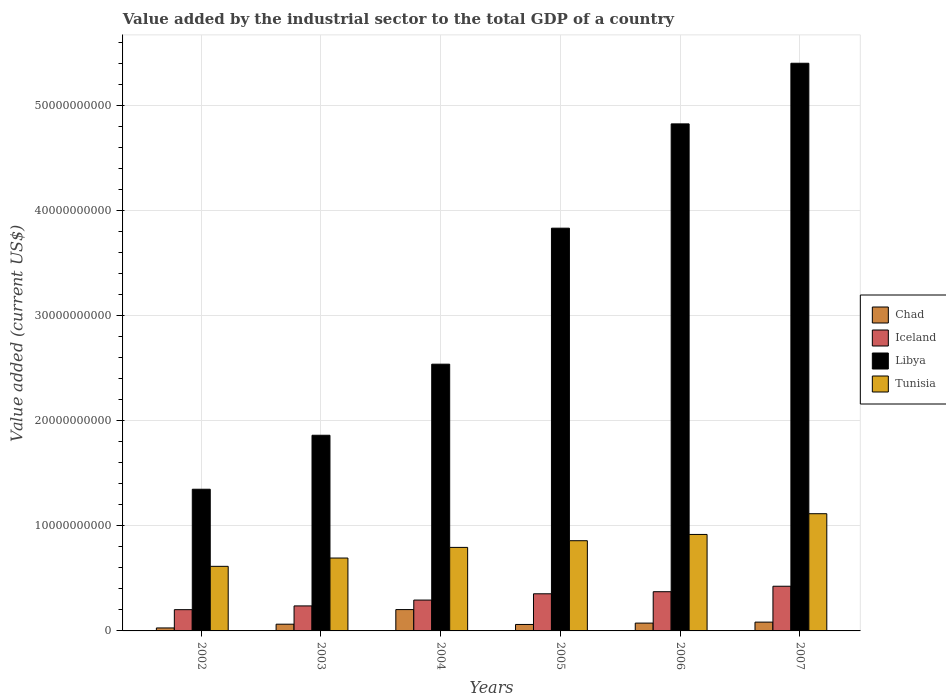How many groups of bars are there?
Make the answer very short. 6. Are the number of bars per tick equal to the number of legend labels?
Make the answer very short. Yes. Are the number of bars on each tick of the X-axis equal?
Provide a short and direct response. Yes. How many bars are there on the 5th tick from the left?
Your response must be concise. 4. How many bars are there on the 3rd tick from the right?
Offer a terse response. 4. What is the label of the 3rd group of bars from the left?
Give a very brief answer. 2004. In how many cases, is the number of bars for a given year not equal to the number of legend labels?
Offer a very short reply. 0. What is the value added by the industrial sector to the total GDP in Chad in 2003?
Your answer should be compact. 6.41e+08. Across all years, what is the maximum value added by the industrial sector to the total GDP in Chad?
Your answer should be compact. 2.03e+09. Across all years, what is the minimum value added by the industrial sector to the total GDP in Iceland?
Your answer should be compact. 2.02e+09. What is the total value added by the industrial sector to the total GDP in Libya in the graph?
Offer a terse response. 1.98e+11. What is the difference between the value added by the industrial sector to the total GDP in Iceland in 2002 and that in 2004?
Give a very brief answer. -9.14e+08. What is the difference between the value added by the industrial sector to the total GDP in Tunisia in 2007 and the value added by the industrial sector to the total GDP in Chad in 2006?
Provide a succinct answer. 1.04e+1. What is the average value added by the industrial sector to the total GDP in Iceland per year?
Your response must be concise. 3.14e+09. In the year 2004, what is the difference between the value added by the industrial sector to the total GDP in Iceland and value added by the industrial sector to the total GDP in Tunisia?
Give a very brief answer. -5.01e+09. What is the ratio of the value added by the industrial sector to the total GDP in Chad in 2003 to that in 2004?
Provide a succinct answer. 0.32. Is the difference between the value added by the industrial sector to the total GDP in Iceland in 2004 and 2007 greater than the difference between the value added by the industrial sector to the total GDP in Tunisia in 2004 and 2007?
Ensure brevity in your answer.  Yes. What is the difference between the highest and the second highest value added by the industrial sector to the total GDP in Chad?
Your answer should be compact. 1.19e+09. What is the difference between the highest and the lowest value added by the industrial sector to the total GDP in Chad?
Provide a short and direct response. 1.75e+09. In how many years, is the value added by the industrial sector to the total GDP in Chad greater than the average value added by the industrial sector to the total GDP in Chad taken over all years?
Provide a short and direct response. 1. Is the sum of the value added by the industrial sector to the total GDP in Iceland in 2003 and 2007 greater than the maximum value added by the industrial sector to the total GDP in Chad across all years?
Provide a short and direct response. Yes. What does the 2nd bar from the left in 2007 represents?
Offer a terse response. Iceland. What does the 3rd bar from the right in 2007 represents?
Make the answer very short. Iceland. How many years are there in the graph?
Provide a succinct answer. 6. What is the difference between two consecutive major ticks on the Y-axis?
Your answer should be compact. 1.00e+1. Are the values on the major ticks of Y-axis written in scientific E-notation?
Your response must be concise. No. Does the graph contain any zero values?
Offer a very short reply. No. Where does the legend appear in the graph?
Offer a terse response. Center right. How many legend labels are there?
Your answer should be compact. 4. What is the title of the graph?
Your response must be concise. Value added by the industrial sector to the total GDP of a country. Does "Kiribati" appear as one of the legend labels in the graph?
Your response must be concise. No. What is the label or title of the Y-axis?
Provide a succinct answer. Value added (current US$). What is the Value added (current US$) of Chad in 2002?
Your response must be concise. 2.83e+08. What is the Value added (current US$) in Iceland in 2002?
Offer a terse response. 2.02e+09. What is the Value added (current US$) in Libya in 2002?
Keep it short and to the point. 1.35e+1. What is the Value added (current US$) in Tunisia in 2002?
Offer a very short reply. 6.15e+09. What is the Value added (current US$) of Chad in 2003?
Provide a short and direct response. 6.41e+08. What is the Value added (current US$) in Iceland in 2003?
Keep it short and to the point. 2.38e+09. What is the Value added (current US$) in Libya in 2003?
Your answer should be very brief. 1.86e+1. What is the Value added (current US$) of Tunisia in 2003?
Make the answer very short. 6.94e+09. What is the Value added (current US$) in Chad in 2004?
Your response must be concise. 2.03e+09. What is the Value added (current US$) of Iceland in 2004?
Offer a terse response. 2.94e+09. What is the Value added (current US$) in Libya in 2004?
Offer a very short reply. 2.54e+1. What is the Value added (current US$) in Tunisia in 2004?
Make the answer very short. 7.95e+09. What is the Value added (current US$) of Chad in 2005?
Provide a short and direct response. 6.14e+08. What is the Value added (current US$) in Iceland in 2005?
Offer a very short reply. 3.53e+09. What is the Value added (current US$) in Libya in 2005?
Make the answer very short. 3.83e+1. What is the Value added (current US$) in Tunisia in 2005?
Your answer should be very brief. 8.59e+09. What is the Value added (current US$) in Chad in 2006?
Your answer should be compact. 7.45e+08. What is the Value added (current US$) of Iceland in 2006?
Your answer should be compact. 3.73e+09. What is the Value added (current US$) of Libya in 2006?
Provide a short and direct response. 4.83e+1. What is the Value added (current US$) in Tunisia in 2006?
Your answer should be compact. 9.18e+09. What is the Value added (current US$) of Chad in 2007?
Make the answer very short. 8.38e+08. What is the Value added (current US$) of Iceland in 2007?
Offer a terse response. 4.25e+09. What is the Value added (current US$) in Libya in 2007?
Offer a terse response. 5.40e+1. What is the Value added (current US$) of Tunisia in 2007?
Offer a very short reply. 1.12e+1. Across all years, what is the maximum Value added (current US$) of Chad?
Offer a terse response. 2.03e+09. Across all years, what is the maximum Value added (current US$) of Iceland?
Offer a very short reply. 4.25e+09. Across all years, what is the maximum Value added (current US$) in Libya?
Give a very brief answer. 5.40e+1. Across all years, what is the maximum Value added (current US$) of Tunisia?
Your answer should be very brief. 1.12e+1. Across all years, what is the minimum Value added (current US$) in Chad?
Provide a short and direct response. 2.83e+08. Across all years, what is the minimum Value added (current US$) in Iceland?
Your answer should be compact. 2.02e+09. Across all years, what is the minimum Value added (current US$) in Libya?
Your answer should be compact. 1.35e+1. Across all years, what is the minimum Value added (current US$) in Tunisia?
Ensure brevity in your answer.  6.15e+09. What is the total Value added (current US$) in Chad in the graph?
Give a very brief answer. 5.15e+09. What is the total Value added (current US$) of Iceland in the graph?
Offer a terse response. 1.89e+1. What is the total Value added (current US$) in Libya in the graph?
Keep it short and to the point. 1.98e+11. What is the total Value added (current US$) in Tunisia in the graph?
Make the answer very short. 5.00e+1. What is the difference between the Value added (current US$) in Chad in 2002 and that in 2003?
Give a very brief answer. -3.57e+08. What is the difference between the Value added (current US$) of Iceland in 2002 and that in 2003?
Your response must be concise. -3.58e+08. What is the difference between the Value added (current US$) of Libya in 2002 and that in 2003?
Ensure brevity in your answer.  -5.14e+09. What is the difference between the Value added (current US$) in Tunisia in 2002 and that in 2003?
Your answer should be very brief. -7.89e+08. What is the difference between the Value added (current US$) in Chad in 2002 and that in 2004?
Offer a very short reply. -1.75e+09. What is the difference between the Value added (current US$) of Iceland in 2002 and that in 2004?
Your answer should be very brief. -9.14e+08. What is the difference between the Value added (current US$) in Libya in 2002 and that in 2004?
Ensure brevity in your answer.  -1.19e+1. What is the difference between the Value added (current US$) of Tunisia in 2002 and that in 2004?
Your answer should be very brief. -1.80e+09. What is the difference between the Value added (current US$) of Chad in 2002 and that in 2005?
Provide a short and direct response. -3.31e+08. What is the difference between the Value added (current US$) of Iceland in 2002 and that in 2005?
Your answer should be very brief. -1.51e+09. What is the difference between the Value added (current US$) in Libya in 2002 and that in 2005?
Make the answer very short. -2.48e+1. What is the difference between the Value added (current US$) in Tunisia in 2002 and that in 2005?
Make the answer very short. -2.44e+09. What is the difference between the Value added (current US$) of Chad in 2002 and that in 2006?
Offer a very short reply. -4.61e+08. What is the difference between the Value added (current US$) of Iceland in 2002 and that in 2006?
Your answer should be very brief. -1.71e+09. What is the difference between the Value added (current US$) in Libya in 2002 and that in 2006?
Your answer should be compact. -3.48e+1. What is the difference between the Value added (current US$) in Tunisia in 2002 and that in 2006?
Ensure brevity in your answer.  -3.03e+09. What is the difference between the Value added (current US$) of Chad in 2002 and that in 2007?
Offer a terse response. -5.55e+08. What is the difference between the Value added (current US$) in Iceland in 2002 and that in 2007?
Keep it short and to the point. -2.23e+09. What is the difference between the Value added (current US$) in Libya in 2002 and that in 2007?
Offer a very short reply. -4.05e+1. What is the difference between the Value added (current US$) of Tunisia in 2002 and that in 2007?
Keep it short and to the point. -5.01e+09. What is the difference between the Value added (current US$) of Chad in 2003 and that in 2004?
Offer a terse response. -1.39e+09. What is the difference between the Value added (current US$) in Iceland in 2003 and that in 2004?
Keep it short and to the point. -5.56e+08. What is the difference between the Value added (current US$) of Libya in 2003 and that in 2004?
Offer a very short reply. -6.77e+09. What is the difference between the Value added (current US$) of Tunisia in 2003 and that in 2004?
Provide a short and direct response. -1.01e+09. What is the difference between the Value added (current US$) in Chad in 2003 and that in 2005?
Provide a short and direct response. 2.67e+07. What is the difference between the Value added (current US$) of Iceland in 2003 and that in 2005?
Give a very brief answer. -1.15e+09. What is the difference between the Value added (current US$) of Libya in 2003 and that in 2005?
Provide a short and direct response. -1.97e+1. What is the difference between the Value added (current US$) in Tunisia in 2003 and that in 2005?
Provide a succinct answer. -1.65e+09. What is the difference between the Value added (current US$) of Chad in 2003 and that in 2006?
Provide a short and direct response. -1.04e+08. What is the difference between the Value added (current US$) of Iceland in 2003 and that in 2006?
Make the answer very short. -1.35e+09. What is the difference between the Value added (current US$) of Libya in 2003 and that in 2006?
Offer a terse response. -2.96e+1. What is the difference between the Value added (current US$) of Tunisia in 2003 and that in 2006?
Your answer should be compact. -2.25e+09. What is the difference between the Value added (current US$) of Chad in 2003 and that in 2007?
Offer a terse response. -1.98e+08. What is the difference between the Value added (current US$) of Iceland in 2003 and that in 2007?
Your answer should be very brief. -1.87e+09. What is the difference between the Value added (current US$) of Libya in 2003 and that in 2007?
Give a very brief answer. -3.54e+1. What is the difference between the Value added (current US$) of Tunisia in 2003 and that in 2007?
Provide a succinct answer. -4.22e+09. What is the difference between the Value added (current US$) of Chad in 2004 and that in 2005?
Offer a very short reply. 1.42e+09. What is the difference between the Value added (current US$) in Iceland in 2004 and that in 2005?
Ensure brevity in your answer.  -5.97e+08. What is the difference between the Value added (current US$) in Libya in 2004 and that in 2005?
Your response must be concise. -1.29e+1. What is the difference between the Value added (current US$) of Tunisia in 2004 and that in 2005?
Your response must be concise. -6.36e+08. What is the difference between the Value added (current US$) of Chad in 2004 and that in 2006?
Keep it short and to the point. 1.29e+09. What is the difference between the Value added (current US$) in Iceland in 2004 and that in 2006?
Keep it short and to the point. -7.95e+08. What is the difference between the Value added (current US$) in Libya in 2004 and that in 2006?
Provide a short and direct response. -2.29e+1. What is the difference between the Value added (current US$) of Tunisia in 2004 and that in 2006?
Your answer should be compact. -1.23e+09. What is the difference between the Value added (current US$) of Chad in 2004 and that in 2007?
Offer a terse response. 1.19e+09. What is the difference between the Value added (current US$) in Iceland in 2004 and that in 2007?
Make the answer very short. -1.32e+09. What is the difference between the Value added (current US$) in Libya in 2004 and that in 2007?
Your response must be concise. -2.86e+1. What is the difference between the Value added (current US$) in Tunisia in 2004 and that in 2007?
Make the answer very short. -3.21e+09. What is the difference between the Value added (current US$) in Chad in 2005 and that in 2006?
Provide a short and direct response. -1.31e+08. What is the difference between the Value added (current US$) of Iceland in 2005 and that in 2006?
Your answer should be compact. -1.99e+08. What is the difference between the Value added (current US$) in Libya in 2005 and that in 2006?
Offer a very short reply. -9.93e+09. What is the difference between the Value added (current US$) in Tunisia in 2005 and that in 2006?
Provide a short and direct response. -5.96e+08. What is the difference between the Value added (current US$) of Chad in 2005 and that in 2007?
Make the answer very short. -2.24e+08. What is the difference between the Value added (current US$) of Iceland in 2005 and that in 2007?
Give a very brief answer. -7.18e+08. What is the difference between the Value added (current US$) of Libya in 2005 and that in 2007?
Your answer should be compact. -1.57e+1. What is the difference between the Value added (current US$) in Tunisia in 2005 and that in 2007?
Keep it short and to the point. -2.57e+09. What is the difference between the Value added (current US$) of Chad in 2006 and that in 2007?
Your response must be concise. -9.36e+07. What is the difference between the Value added (current US$) in Iceland in 2006 and that in 2007?
Ensure brevity in your answer.  -5.20e+08. What is the difference between the Value added (current US$) of Libya in 2006 and that in 2007?
Keep it short and to the point. -5.77e+09. What is the difference between the Value added (current US$) of Tunisia in 2006 and that in 2007?
Make the answer very short. -1.97e+09. What is the difference between the Value added (current US$) in Chad in 2002 and the Value added (current US$) in Iceland in 2003?
Your response must be concise. -2.10e+09. What is the difference between the Value added (current US$) in Chad in 2002 and the Value added (current US$) in Libya in 2003?
Your response must be concise. -1.83e+1. What is the difference between the Value added (current US$) of Chad in 2002 and the Value added (current US$) of Tunisia in 2003?
Your answer should be compact. -6.65e+09. What is the difference between the Value added (current US$) of Iceland in 2002 and the Value added (current US$) of Libya in 2003?
Ensure brevity in your answer.  -1.66e+1. What is the difference between the Value added (current US$) in Iceland in 2002 and the Value added (current US$) in Tunisia in 2003?
Make the answer very short. -4.91e+09. What is the difference between the Value added (current US$) in Libya in 2002 and the Value added (current US$) in Tunisia in 2003?
Offer a terse response. 6.55e+09. What is the difference between the Value added (current US$) in Chad in 2002 and the Value added (current US$) in Iceland in 2004?
Your response must be concise. -2.65e+09. What is the difference between the Value added (current US$) in Chad in 2002 and the Value added (current US$) in Libya in 2004?
Provide a short and direct response. -2.51e+1. What is the difference between the Value added (current US$) of Chad in 2002 and the Value added (current US$) of Tunisia in 2004?
Provide a short and direct response. -7.67e+09. What is the difference between the Value added (current US$) of Iceland in 2002 and the Value added (current US$) of Libya in 2004?
Your answer should be compact. -2.34e+1. What is the difference between the Value added (current US$) of Iceland in 2002 and the Value added (current US$) of Tunisia in 2004?
Give a very brief answer. -5.93e+09. What is the difference between the Value added (current US$) of Libya in 2002 and the Value added (current US$) of Tunisia in 2004?
Your answer should be compact. 5.53e+09. What is the difference between the Value added (current US$) in Chad in 2002 and the Value added (current US$) in Iceland in 2005?
Offer a terse response. -3.25e+09. What is the difference between the Value added (current US$) of Chad in 2002 and the Value added (current US$) of Libya in 2005?
Provide a short and direct response. -3.80e+1. What is the difference between the Value added (current US$) in Chad in 2002 and the Value added (current US$) in Tunisia in 2005?
Give a very brief answer. -8.30e+09. What is the difference between the Value added (current US$) of Iceland in 2002 and the Value added (current US$) of Libya in 2005?
Give a very brief answer. -3.63e+1. What is the difference between the Value added (current US$) in Iceland in 2002 and the Value added (current US$) in Tunisia in 2005?
Your answer should be compact. -6.56e+09. What is the difference between the Value added (current US$) in Libya in 2002 and the Value added (current US$) in Tunisia in 2005?
Give a very brief answer. 4.90e+09. What is the difference between the Value added (current US$) in Chad in 2002 and the Value added (current US$) in Iceland in 2006?
Ensure brevity in your answer.  -3.45e+09. What is the difference between the Value added (current US$) in Chad in 2002 and the Value added (current US$) in Libya in 2006?
Keep it short and to the point. -4.80e+1. What is the difference between the Value added (current US$) in Chad in 2002 and the Value added (current US$) in Tunisia in 2006?
Provide a short and direct response. -8.90e+09. What is the difference between the Value added (current US$) of Iceland in 2002 and the Value added (current US$) of Libya in 2006?
Give a very brief answer. -4.62e+1. What is the difference between the Value added (current US$) of Iceland in 2002 and the Value added (current US$) of Tunisia in 2006?
Make the answer very short. -7.16e+09. What is the difference between the Value added (current US$) of Libya in 2002 and the Value added (current US$) of Tunisia in 2006?
Your answer should be very brief. 4.30e+09. What is the difference between the Value added (current US$) of Chad in 2002 and the Value added (current US$) of Iceland in 2007?
Make the answer very short. -3.97e+09. What is the difference between the Value added (current US$) of Chad in 2002 and the Value added (current US$) of Libya in 2007?
Provide a succinct answer. -5.37e+1. What is the difference between the Value added (current US$) in Chad in 2002 and the Value added (current US$) in Tunisia in 2007?
Make the answer very short. -1.09e+1. What is the difference between the Value added (current US$) of Iceland in 2002 and the Value added (current US$) of Libya in 2007?
Provide a succinct answer. -5.20e+1. What is the difference between the Value added (current US$) in Iceland in 2002 and the Value added (current US$) in Tunisia in 2007?
Your answer should be very brief. -9.13e+09. What is the difference between the Value added (current US$) in Libya in 2002 and the Value added (current US$) in Tunisia in 2007?
Give a very brief answer. 2.33e+09. What is the difference between the Value added (current US$) of Chad in 2003 and the Value added (current US$) of Iceland in 2004?
Provide a succinct answer. -2.30e+09. What is the difference between the Value added (current US$) of Chad in 2003 and the Value added (current US$) of Libya in 2004?
Your response must be concise. -2.47e+1. What is the difference between the Value added (current US$) in Chad in 2003 and the Value added (current US$) in Tunisia in 2004?
Offer a terse response. -7.31e+09. What is the difference between the Value added (current US$) of Iceland in 2003 and the Value added (current US$) of Libya in 2004?
Keep it short and to the point. -2.30e+1. What is the difference between the Value added (current US$) of Iceland in 2003 and the Value added (current US$) of Tunisia in 2004?
Your answer should be compact. -5.57e+09. What is the difference between the Value added (current US$) in Libya in 2003 and the Value added (current US$) in Tunisia in 2004?
Offer a very short reply. 1.07e+1. What is the difference between the Value added (current US$) in Chad in 2003 and the Value added (current US$) in Iceland in 2005?
Your response must be concise. -2.89e+09. What is the difference between the Value added (current US$) of Chad in 2003 and the Value added (current US$) of Libya in 2005?
Your answer should be very brief. -3.77e+1. What is the difference between the Value added (current US$) in Chad in 2003 and the Value added (current US$) in Tunisia in 2005?
Provide a succinct answer. -7.94e+09. What is the difference between the Value added (current US$) of Iceland in 2003 and the Value added (current US$) of Libya in 2005?
Provide a short and direct response. -3.59e+1. What is the difference between the Value added (current US$) of Iceland in 2003 and the Value added (current US$) of Tunisia in 2005?
Give a very brief answer. -6.20e+09. What is the difference between the Value added (current US$) of Libya in 2003 and the Value added (current US$) of Tunisia in 2005?
Ensure brevity in your answer.  1.00e+1. What is the difference between the Value added (current US$) in Chad in 2003 and the Value added (current US$) in Iceland in 2006?
Give a very brief answer. -3.09e+09. What is the difference between the Value added (current US$) of Chad in 2003 and the Value added (current US$) of Libya in 2006?
Your answer should be compact. -4.76e+1. What is the difference between the Value added (current US$) in Chad in 2003 and the Value added (current US$) in Tunisia in 2006?
Make the answer very short. -8.54e+09. What is the difference between the Value added (current US$) in Iceland in 2003 and the Value added (current US$) in Libya in 2006?
Provide a short and direct response. -4.59e+1. What is the difference between the Value added (current US$) in Iceland in 2003 and the Value added (current US$) in Tunisia in 2006?
Ensure brevity in your answer.  -6.80e+09. What is the difference between the Value added (current US$) of Libya in 2003 and the Value added (current US$) of Tunisia in 2006?
Make the answer very short. 9.44e+09. What is the difference between the Value added (current US$) in Chad in 2003 and the Value added (current US$) in Iceland in 2007?
Ensure brevity in your answer.  -3.61e+09. What is the difference between the Value added (current US$) in Chad in 2003 and the Value added (current US$) in Libya in 2007?
Offer a very short reply. -5.34e+1. What is the difference between the Value added (current US$) of Chad in 2003 and the Value added (current US$) of Tunisia in 2007?
Your response must be concise. -1.05e+1. What is the difference between the Value added (current US$) of Iceland in 2003 and the Value added (current US$) of Libya in 2007?
Offer a terse response. -5.16e+1. What is the difference between the Value added (current US$) in Iceland in 2003 and the Value added (current US$) in Tunisia in 2007?
Give a very brief answer. -8.77e+09. What is the difference between the Value added (current US$) in Libya in 2003 and the Value added (current US$) in Tunisia in 2007?
Your response must be concise. 7.47e+09. What is the difference between the Value added (current US$) in Chad in 2004 and the Value added (current US$) in Iceland in 2005?
Your response must be concise. -1.50e+09. What is the difference between the Value added (current US$) in Chad in 2004 and the Value added (current US$) in Libya in 2005?
Offer a terse response. -3.63e+1. What is the difference between the Value added (current US$) of Chad in 2004 and the Value added (current US$) of Tunisia in 2005?
Offer a terse response. -6.56e+09. What is the difference between the Value added (current US$) in Iceland in 2004 and the Value added (current US$) in Libya in 2005?
Your answer should be compact. -3.54e+1. What is the difference between the Value added (current US$) of Iceland in 2004 and the Value added (current US$) of Tunisia in 2005?
Provide a succinct answer. -5.65e+09. What is the difference between the Value added (current US$) of Libya in 2004 and the Value added (current US$) of Tunisia in 2005?
Ensure brevity in your answer.  1.68e+1. What is the difference between the Value added (current US$) in Chad in 2004 and the Value added (current US$) in Iceland in 2006?
Offer a very short reply. -1.70e+09. What is the difference between the Value added (current US$) in Chad in 2004 and the Value added (current US$) in Libya in 2006?
Keep it short and to the point. -4.62e+1. What is the difference between the Value added (current US$) of Chad in 2004 and the Value added (current US$) of Tunisia in 2006?
Keep it short and to the point. -7.15e+09. What is the difference between the Value added (current US$) in Iceland in 2004 and the Value added (current US$) in Libya in 2006?
Offer a terse response. -4.53e+1. What is the difference between the Value added (current US$) of Iceland in 2004 and the Value added (current US$) of Tunisia in 2006?
Provide a short and direct response. -6.24e+09. What is the difference between the Value added (current US$) in Libya in 2004 and the Value added (current US$) in Tunisia in 2006?
Your response must be concise. 1.62e+1. What is the difference between the Value added (current US$) of Chad in 2004 and the Value added (current US$) of Iceland in 2007?
Make the answer very short. -2.22e+09. What is the difference between the Value added (current US$) in Chad in 2004 and the Value added (current US$) in Libya in 2007?
Your answer should be compact. -5.20e+1. What is the difference between the Value added (current US$) of Chad in 2004 and the Value added (current US$) of Tunisia in 2007?
Offer a very short reply. -9.12e+09. What is the difference between the Value added (current US$) in Iceland in 2004 and the Value added (current US$) in Libya in 2007?
Ensure brevity in your answer.  -5.11e+1. What is the difference between the Value added (current US$) in Iceland in 2004 and the Value added (current US$) in Tunisia in 2007?
Provide a succinct answer. -8.22e+09. What is the difference between the Value added (current US$) of Libya in 2004 and the Value added (current US$) of Tunisia in 2007?
Provide a short and direct response. 1.42e+1. What is the difference between the Value added (current US$) of Chad in 2005 and the Value added (current US$) of Iceland in 2006?
Offer a terse response. -3.12e+09. What is the difference between the Value added (current US$) in Chad in 2005 and the Value added (current US$) in Libya in 2006?
Give a very brief answer. -4.76e+1. What is the difference between the Value added (current US$) of Chad in 2005 and the Value added (current US$) of Tunisia in 2006?
Ensure brevity in your answer.  -8.57e+09. What is the difference between the Value added (current US$) of Iceland in 2005 and the Value added (current US$) of Libya in 2006?
Provide a short and direct response. -4.47e+1. What is the difference between the Value added (current US$) of Iceland in 2005 and the Value added (current US$) of Tunisia in 2006?
Make the answer very short. -5.65e+09. What is the difference between the Value added (current US$) of Libya in 2005 and the Value added (current US$) of Tunisia in 2006?
Keep it short and to the point. 2.91e+1. What is the difference between the Value added (current US$) of Chad in 2005 and the Value added (current US$) of Iceland in 2007?
Your answer should be very brief. -3.64e+09. What is the difference between the Value added (current US$) in Chad in 2005 and the Value added (current US$) in Libya in 2007?
Offer a terse response. -5.34e+1. What is the difference between the Value added (current US$) of Chad in 2005 and the Value added (current US$) of Tunisia in 2007?
Your answer should be very brief. -1.05e+1. What is the difference between the Value added (current US$) in Iceland in 2005 and the Value added (current US$) in Libya in 2007?
Make the answer very short. -5.05e+1. What is the difference between the Value added (current US$) of Iceland in 2005 and the Value added (current US$) of Tunisia in 2007?
Your response must be concise. -7.62e+09. What is the difference between the Value added (current US$) of Libya in 2005 and the Value added (current US$) of Tunisia in 2007?
Offer a terse response. 2.72e+1. What is the difference between the Value added (current US$) of Chad in 2006 and the Value added (current US$) of Iceland in 2007?
Keep it short and to the point. -3.51e+09. What is the difference between the Value added (current US$) of Chad in 2006 and the Value added (current US$) of Libya in 2007?
Make the answer very short. -5.33e+1. What is the difference between the Value added (current US$) in Chad in 2006 and the Value added (current US$) in Tunisia in 2007?
Your response must be concise. -1.04e+1. What is the difference between the Value added (current US$) in Iceland in 2006 and the Value added (current US$) in Libya in 2007?
Provide a short and direct response. -5.03e+1. What is the difference between the Value added (current US$) of Iceland in 2006 and the Value added (current US$) of Tunisia in 2007?
Provide a succinct answer. -7.42e+09. What is the difference between the Value added (current US$) in Libya in 2006 and the Value added (current US$) in Tunisia in 2007?
Offer a terse response. 3.71e+1. What is the average Value added (current US$) of Chad per year?
Provide a succinct answer. 8.59e+08. What is the average Value added (current US$) in Iceland per year?
Make the answer very short. 3.14e+09. What is the average Value added (current US$) in Libya per year?
Offer a very short reply. 3.30e+1. What is the average Value added (current US$) in Tunisia per year?
Keep it short and to the point. 8.33e+09. In the year 2002, what is the difference between the Value added (current US$) in Chad and Value added (current US$) in Iceland?
Provide a succinct answer. -1.74e+09. In the year 2002, what is the difference between the Value added (current US$) in Chad and Value added (current US$) in Libya?
Your answer should be very brief. -1.32e+1. In the year 2002, what is the difference between the Value added (current US$) of Chad and Value added (current US$) of Tunisia?
Your answer should be very brief. -5.86e+09. In the year 2002, what is the difference between the Value added (current US$) of Iceland and Value added (current US$) of Libya?
Make the answer very short. -1.15e+1. In the year 2002, what is the difference between the Value added (current US$) of Iceland and Value added (current US$) of Tunisia?
Keep it short and to the point. -4.12e+09. In the year 2002, what is the difference between the Value added (current US$) in Libya and Value added (current US$) in Tunisia?
Your answer should be very brief. 7.34e+09. In the year 2003, what is the difference between the Value added (current US$) in Chad and Value added (current US$) in Iceland?
Keep it short and to the point. -1.74e+09. In the year 2003, what is the difference between the Value added (current US$) of Chad and Value added (current US$) of Libya?
Offer a terse response. -1.80e+1. In the year 2003, what is the difference between the Value added (current US$) in Chad and Value added (current US$) in Tunisia?
Keep it short and to the point. -6.29e+09. In the year 2003, what is the difference between the Value added (current US$) in Iceland and Value added (current US$) in Libya?
Give a very brief answer. -1.62e+1. In the year 2003, what is the difference between the Value added (current US$) in Iceland and Value added (current US$) in Tunisia?
Provide a succinct answer. -4.55e+09. In the year 2003, what is the difference between the Value added (current US$) in Libya and Value added (current US$) in Tunisia?
Provide a succinct answer. 1.17e+1. In the year 2004, what is the difference between the Value added (current US$) of Chad and Value added (current US$) of Iceland?
Your response must be concise. -9.07e+08. In the year 2004, what is the difference between the Value added (current US$) of Chad and Value added (current US$) of Libya?
Offer a terse response. -2.34e+1. In the year 2004, what is the difference between the Value added (current US$) in Chad and Value added (current US$) in Tunisia?
Provide a short and direct response. -5.92e+09. In the year 2004, what is the difference between the Value added (current US$) in Iceland and Value added (current US$) in Libya?
Ensure brevity in your answer.  -2.24e+1. In the year 2004, what is the difference between the Value added (current US$) in Iceland and Value added (current US$) in Tunisia?
Offer a very short reply. -5.01e+09. In the year 2004, what is the difference between the Value added (current US$) in Libya and Value added (current US$) in Tunisia?
Keep it short and to the point. 1.74e+1. In the year 2005, what is the difference between the Value added (current US$) in Chad and Value added (current US$) in Iceland?
Keep it short and to the point. -2.92e+09. In the year 2005, what is the difference between the Value added (current US$) of Chad and Value added (current US$) of Libya?
Give a very brief answer. -3.77e+1. In the year 2005, what is the difference between the Value added (current US$) in Chad and Value added (current US$) in Tunisia?
Your answer should be compact. -7.97e+09. In the year 2005, what is the difference between the Value added (current US$) in Iceland and Value added (current US$) in Libya?
Offer a very short reply. -3.48e+1. In the year 2005, what is the difference between the Value added (current US$) in Iceland and Value added (current US$) in Tunisia?
Provide a short and direct response. -5.05e+09. In the year 2005, what is the difference between the Value added (current US$) in Libya and Value added (current US$) in Tunisia?
Provide a short and direct response. 2.97e+1. In the year 2006, what is the difference between the Value added (current US$) in Chad and Value added (current US$) in Iceland?
Give a very brief answer. -2.99e+09. In the year 2006, what is the difference between the Value added (current US$) of Chad and Value added (current US$) of Libya?
Offer a very short reply. -4.75e+1. In the year 2006, what is the difference between the Value added (current US$) in Chad and Value added (current US$) in Tunisia?
Your answer should be very brief. -8.44e+09. In the year 2006, what is the difference between the Value added (current US$) in Iceland and Value added (current US$) in Libya?
Provide a short and direct response. -4.45e+1. In the year 2006, what is the difference between the Value added (current US$) in Iceland and Value added (current US$) in Tunisia?
Offer a very short reply. -5.45e+09. In the year 2006, what is the difference between the Value added (current US$) in Libya and Value added (current US$) in Tunisia?
Offer a very short reply. 3.91e+1. In the year 2007, what is the difference between the Value added (current US$) in Chad and Value added (current US$) in Iceland?
Give a very brief answer. -3.41e+09. In the year 2007, what is the difference between the Value added (current US$) in Chad and Value added (current US$) in Libya?
Make the answer very short. -5.32e+1. In the year 2007, what is the difference between the Value added (current US$) of Chad and Value added (current US$) of Tunisia?
Offer a terse response. -1.03e+1. In the year 2007, what is the difference between the Value added (current US$) of Iceland and Value added (current US$) of Libya?
Your answer should be very brief. -4.98e+1. In the year 2007, what is the difference between the Value added (current US$) of Iceland and Value added (current US$) of Tunisia?
Give a very brief answer. -6.90e+09. In the year 2007, what is the difference between the Value added (current US$) in Libya and Value added (current US$) in Tunisia?
Offer a very short reply. 4.29e+1. What is the ratio of the Value added (current US$) in Chad in 2002 to that in 2003?
Your answer should be compact. 0.44. What is the ratio of the Value added (current US$) in Iceland in 2002 to that in 2003?
Ensure brevity in your answer.  0.85. What is the ratio of the Value added (current US$) in Libya in 2002 to that in 2003?
Ensure brevity in your answer.  0.72. What is the ratio of the Value added (current US$) of Tunisia in 2002 to that in 2003?
Give a very brief answer. 0.89. What is the ratio of the Value added (current US$) in Chad in 2002 to that in 2004?
Offer a very short reply. 0.14. What is the ratio of the Value added (current US$) in Iceland in 2002 to that in 2004?
Provide a short and direct response. 0.69. What is the ratio of the Value added (current US$) in Libya in 2002 to that in 2004?
Ensure brevity in your answer.  0.53. What is the ratio of the Value added (current US$) of Tunisia in 2002 to that in 2004?
Keep it short and to the point. 0.77. What is the ratio of the Value added (current US$) of Chad in 2002 to that in 2005?
Make the answer very short. 0.46. What is the ratio of the Value added (current US$) of Iceland in 2002 to that in 2005?
Make the answer very short. 0.57. What is the ratio of the Value added (current US$) of Libya in 2002 to that in 2005?
Your response must be concise. 0.35. What is the ratio of the Value added (current US$) of Tunisia in 2002 to that in 2005?
Keep it short and to the point. 0.72. What is the ratio of the Value added (current US$) in Chad in 2002 to that in 2006?
Your response must be concise. 0.38. What is the ratio of the Value added (current US$) of Iceland in 2002 to that in 2006?
Your response must be concise. 0.54. What is the ratio of the Value added (current US$) in Libya in 2002 to that in 2006?
Provide a succinct answer. 0.28. What is the ratio of the Value added (current US$) of Tunisia in 2002 to that in 2006?
Your answer should be compact. 0.67. What is the ratio of the Value added (current US$) of Chad in 2002 to that in 2007?
Keep it short and to the point. 0.34. What is the ratio of the Value added (current US$) of Iceland in 2002 to that in 2007?
Offer a very short reply. 0.48. What is the ratio of the Value added (current US$) of Libya in 2002 to that in 2007?
Ensure brevity in your answer.  0.25. What is the ratio of the Value added (current US$) of Tunisia in 2002 to that in 2007?
Your answer should be compact. 0.55. What is the ratio of the Value added (current US$) in Chad in 2003 to that in 2004?
Make the answer very short. 0.32. What is the ratio of the Value added (current US$) in Iceland in 2003 to that in 2004?
Offer a terse response. 0.81. What is the ratio of the Value added (current US$) in Libya in 2003 to that in 2004?
Give a very brief answer. 0.73. What is the ratio of the Value added (current US$) of Tunisia in 2003 to that in 2004?
Offer a terse response. 0.87. What is the ratio of the Value added (current US$) of Chad in 2003 to that in 2005?
Give a very brief answer. 1.04. What is the ratio of the Value added (current US$) of Iceland in 2003 to that in 2005?
Offer a very short reply. 0.67. What is the ratio of the Value added (current US$) of Libya in 2003 to that in 2005?
Your answer should be compact. 0.49. What is the ratio of the Value added (current US$) of Tunisia in 2003 to that in 2005?
Offer a terse response. 0.81. What is the ratio of the Value added (current US$) in Chad in 2003 to that in 2006?
Offer a very short reply. 0.86. What is the ratio of the Value added (current US$) in Iceland in 2003 to that in 2006?
Your answer should be compact. 0.64. What is the ratio of the Value added (current US$) of Libya in 2003 to that in 2006?
Your answer should be very brief. 0.39. What is the ratio of the Value added (current US$) in Tunisia in 2003 to that in 2006?
Your answer should be compact. 0.76. What is the ratio of the Value added (current US$) in Chad in 2003 to that in 2007?
Give a very brief answer. 0.76. What is the ratio of the Value added (current US$) of Iceland in 2003 to that in 2007?
Make the answer very short. 0.56. What is the ratio of the Value added (current US$) in Libya in 2003 to that in 2007?
Offer a terse response. 0.34. What is the ratio of the Value added (current US$) in Tunisia in 2003 to that in 2007?
Offer a very short reply. 0.62. What is the ratio of the Value added (current US$) of Chad in 2004 to that in 2005?
Provide a short and direct response. 3.31. What is the ratio of the Value added (current US$) in Iceland in 2004 to that in 2005?
Give a very brief answer. 0.83. What is the ratio of the Value added (current US$) of Libya in 2004 to that in 2005?
Your answer should be compact. 0.66. What is the ratio of the Value added (current US$) of Tunisia in 2004 to that in 2005?
Your answer should be very brief. 0.93. What is the ratio of the Value added (current US$) of Chad in 2004 to that in 2006?
Make the answer very short. 2.73. What is the ratio of the Value added (current US$) of Iceland in 2004 to that in 2006?
Give a very brief answer. 0.79. What is the ratio of the Value added (current US$) of Libya in 2004 to that in 2006?
Ensure brevity in your answer.  0.53. What is the ratio of the Value added (current US$) of Tunisia in 2004 to that in 2006?
Your answer should be compact. 0.87. What is the ratio of the Value added (current US$) of Chad in 2004 to that in 2007?
Provide a succinct answer. 2.42. What is the ratio of the Value added (current US$) in Iceland in 2004 to that in 2007?
Make the answer very short. 0.69. What is the ratio of the Value added (current US$) of Libya in 2004 to that in 2007?
Keep it short and to the point. 0.47. What is the ratio of the Value added (current US$) of Tunisia in 2004 to that in 2007?
Provide a succinct answer. 0.71. What is the ratio of the Value added (current US$) of Chad in 2005 to that in 2006?
Your response must be concise. 0.82. What is the ratio of the Value added (current US$) of Iceland in 2005 to that in 2006?
Offer a very short reply. 0.95. What is the ratio of the Value added (current US$) in Libya in 2005 to that in 2006?
Give a very brief answer. 0.79. What is the ratio of the Value added (current US$) in Tunisia in 2005 to that in 2006?
Keep it short and to the point. 0.94. What is the ratio of the Value added (current US$) of Chad in 2005 to that in 2007?
Provide a short and direct response. 0.73. What is the ratio of the Value added (current US$) of Iceland in 2005 to that in 2007?
Offer a terse response. 0.83. What is the ratio of the Value added (current US$) of Libya in 2005 to that in 2007?
Ensure brevity in your answer.  0.71. What is the ratio of the Value added (current US$) of Tunisia in 2005 to that in 2007?
Offer a very short reply. 0.77. What is the ratio of the Value added (current US$) in Chad in 2006 to that in 2007?
Give a very brief answer. 0.89. What is the ratio of the Value added (current US$) in Iceland in 2006 to that in 2007?
Your answer should be compact. 0.88. What is the ratio of the Value added (current US$) in Libya in 2006 to that in 2007?
Provide a short and direct response. 0.89. What is the ratio of the Value added (current US$) of Tunisia in 2006 to that in 2007?
Provide a short and direct response. 0.82. What is the difference between the highest and the second highest Value added (current US$) of Chad?
Offer a terse response. 1.19e+09. What is the difference between the highest and the second highest Value added (current US$) in Iceland?
Make the answer very short. 5.20e+08. What is the difference between the highest and the second highest Value added (current US$) in Libya?
Keep it short and to the point. 5.77e+09. What is the difference between the highest and the second highest Value added (current US$) in Tunisia?
Ensure brevity in your answer.  1.97e+09. What is the difference between the highest and the lowest Value added (current US$) of Chad?
Your response must be concise. 1.75e+09. What is the difference between the highest and the lowest Value added (current US$) of Iceland?
Your answer should be compact. 2.23e+09. What is the difference between the highest and the lowest Value added (current US$) in Libya?
Make the answer very short. 4.05e+1. What is the difference between the highest and the lowest Value added (current US$) in Tunisia?
Your answer should be compact. 5.01e+09. 